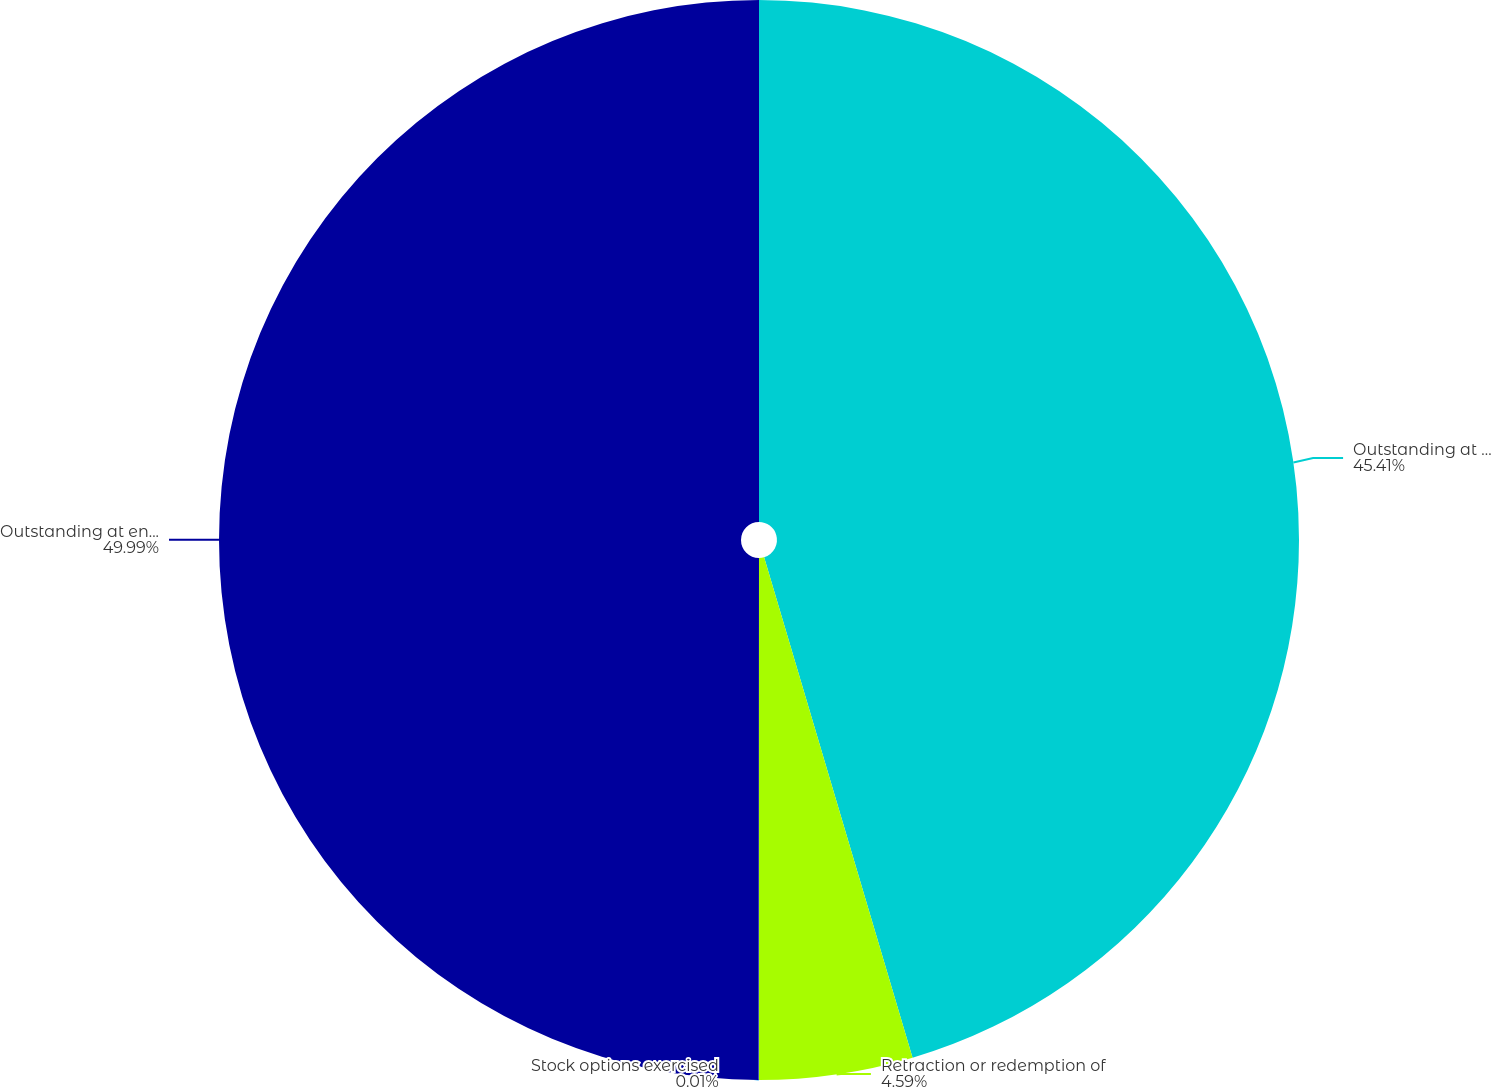<chart> <loc_0><loc_0><loc_500><loc_500><pie_chart><fcel>Outstanding at beginning of<fcel>Retraction or redemption of<fcel>Stock options exercised<fcel>Outstanding at end of year<nl><fcel>45.41%<fcel>4.59%<fcel>0.01%<fcel>49.99%<nl></chart> 